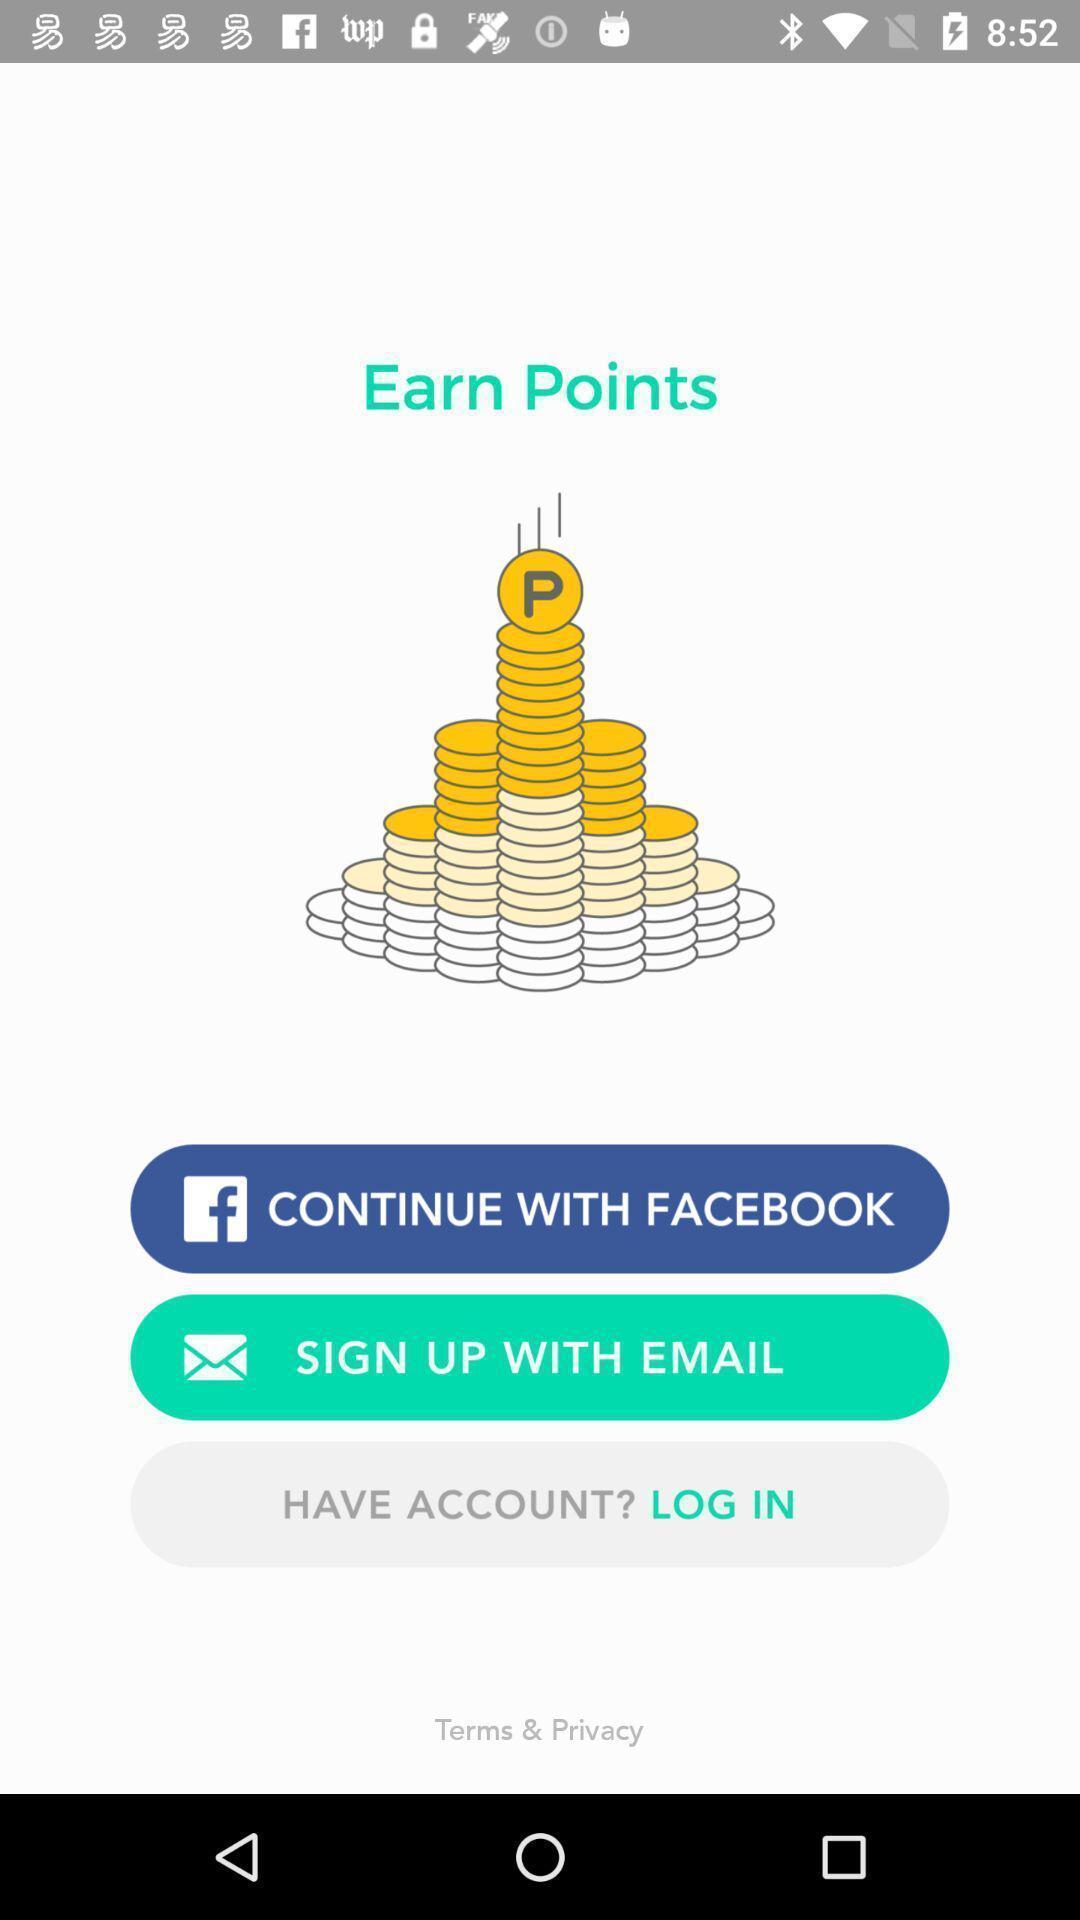Describe the key features of this screenshot. Sign up page. 